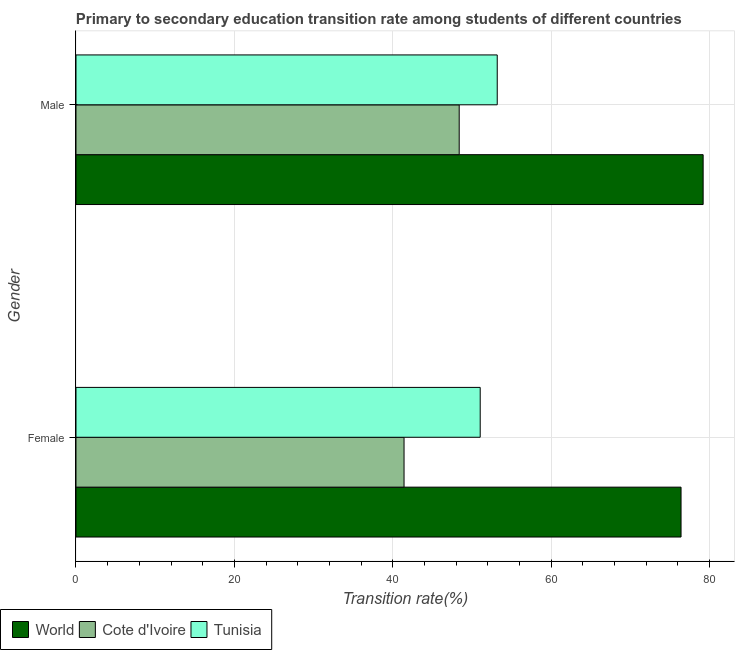Are the number of bars per tick equal to the number of legend labels?
Offer a very short reply. Yes. How many bars are there on the 1st tick from the top?
Make the answer very short. 3. What is the label of the 1st group of bars from the top?
Ensure brevity in your answer.  Male. What is the transition rate among male students in World?
Give a very brief answer. 79.2. Across all countries, what is the maximum transition rate among female students?
Give a very brief answer. 76.41. Across all countries, what is the minimum transition rate among female students?
Give a very brief answer. 41.43. In which country was the transition rate among male students maximum?
Your response must be concise. World. In which country was the transition rate among male students minimum?
Your answer should be compact. Cote d'Ivoire. What is the total transition rate among female students in the graph?
Your response must be concise. 168.88. What is the difference between the transition rate among male students in Tunisia and that in Cote d'Ivoire?
Your response must be concise. 4.8. What is the difference between the transition rate among male students in Tunisia and the transition rate among female students in World?
Offer a terse response. -23.21. What is the average transition rate among male students per country?
Offer a very short reply. 60.26. What is the difference between the transition rate among male students and transition rate among female students in Tunisia?
Make the answer very short. 2.15. In how many countries, is the transition rate among female students greater than 60 %?
Provide a succinct answer. 1. What is the ratio of the transition rate among female students in World to that in Cote d'Ivoire?
Ensure brevity in your answer.  1.84. Is the transition rate among male students in Cote d'Ivoire less than that in Tunisia?
Provide a short and direct response. Yes. Are the values on the major ticks of X-axis written in scientific E-notation?
Give a very brief answer. No. How are the legend labels stacked?
Ensure brevity in your answer.  Horizontal. What is the title of the graph?
Your answer should be compact. Primary to secondary education transition rate among students of different countries. What is the label or title of the X-axis?
Offer a terse response. Transition rate(%). What is the label or title of the Y-axis?
Ensure brevity in your answer.  Gender. What is the Transition rate(%) in World in Female?
Provide a short and direct response. 76.41. What is the Transition rate(%) of Cote d'Ivoire in Female?
Offer a very short reply. 41.43. What is the Transition rate(%) in Tunisia in Female?
Your answer should be very brief. 51.05. What is the Transition rate(%) of World in Male?
Your answer should be compact. 79.2. What is the Transition rate(%) of Cote d'Ivoire in Male?
Keep it short and to the point. 48.39. What is the Transition rate(%) of Tunisia in Male?
Offer a very short reply. 53.2. Across all Gender, what is the maximum Transition rate(%) of World?
Give a very brief answer. 79.2. Across all Gender, what is the maximum Transition rate(%) of Cote d'Ivoire?
Your answer should be very brief. 48.39. Across all Gender, what is the maximum Transition rate(%) in Tunisia?
Give a very brief answer. 53.2. Across all Gender, what is the minimum Transition rate(%) in World?
Provide a short and direct response. 76.41. Across all Gender, what is the minimum Transition rate(%) in Cote d'Ivoire?
Make the answer very short. 41.43. Across all Gender, what is the minimum Transition rate(%) in Tunisia?
Your response must be concise. 51.05. What is the total Transition rate(%) in World in the graph?
Offer a terse response. 155.61. What is the total Transition rate(%) of Cote d'Ivoire in the graph?
Keep it short and to the point. 89.82. What is the total Transition rate(%) of Tunisia in the graph?
Provide a short and direct response. 104.24. What is the difference between the Transition rate(%) of World in Female and that in Male?
Provide a succinct answer. -2.79. What is the difference between the Transition rate(%) in Cote d'Ivoire in Female and that in Male?
Give a very brief answer. -6.97. What is the difference between the Transition rate(%) of Tunisia in Female and that in Male?
Offer a very short reply. -2.15. What is the difference between the Transition rate(%) of World in Female and the Transition rate(%) of Cote d'Ivoire in Male?
Ensure brevity in your answer.  28.02. What is the difference between the Transition rate(%) in World in Female and the Transition rate(%) in Tunisia in Male?
Provide a short and direct response. 23.21. What is the difference between the Transition rate(%) in Cote d'Ivoire in Female and the Transition rate(%) in Tunisia in Male?
Keep it short and to the point. -11.77. What is the average Transition rate(%) of World per Gender?
Make the answer very short. 77.8. What is the average Transition rate(%) in Cote d'Ivoire per Gender?
Ensure brevity in your answer.  44.91. What is the average Transition rate(%) of Tunisia per Gender?
Provide a short and direct response. 52.12. What is the difference between the Transition rate(%) in World and Transition rate(%) in Cote d'Ivoire in Female?
Your answer should be compact. 34.98. What is the difference between the Transition rate(%) of World and Transition rate(%) of Tunisia in Female?
Provide a short and direct response. 25.36. What is the difference between the Transition rate(%) in Cote d'Ivoire and Transition rate(%) in Tunisia in Female?
Your answer should be very brief. -9.62. What is the difference between the Transition rate(%) of World and Transition rate(%) of Cote d'Ivoire in Male?
Provide a succinct answer. 30.81. What is the difference between the Transition rate(%) of World and Transition rate(%) of Tunisia in Male?
Offer a terse response. 26. What is the difference between the Transition rate(%) in Cote d'Ivoire and Transition rate(%) in Tunisia in Male?
Your answer should be compact. -4.8. What is the ratio of the Transition rate(%) in World in Female to that in Male?
Make the answer very short. 0.96. What is the ratio of the Transition rate(%) of Cote d'Ivoire in Female to that in Male?
Your answer should be very brief. 0.86. What is the ratio of the Transition rate(%) of Tunisia in Female to that in Male?
Provide a short and direct response. 0.96. What is the difference between the highest and the second highest Transition rate(%) of World?
Keep it short and to the point. 2.79. What is the difference between the highest and the second highest Transition rate(%) in Cote d'Ivoire?
Your answer should be very brief. 6.97. What is the difference between the highest and the second highest Transition rate(%) of Tunisia?
Your answer should be very brief. 2.15. What is the difference between the highest and the lowest Transition rate(%) of World?
Provide a succinct answer. 2.79. What is the difference between the highest and the lowest Transition rate(%) in Cote d'Ivoire?
Your response must be concise. 6.97. What is the difference between the highest and the lowest Transition rate(%) in Tunisia?
Make the answer very short. 2.15. 